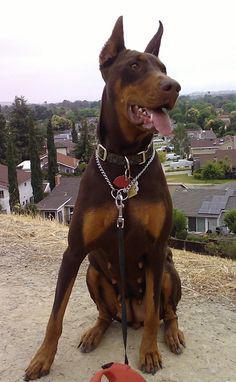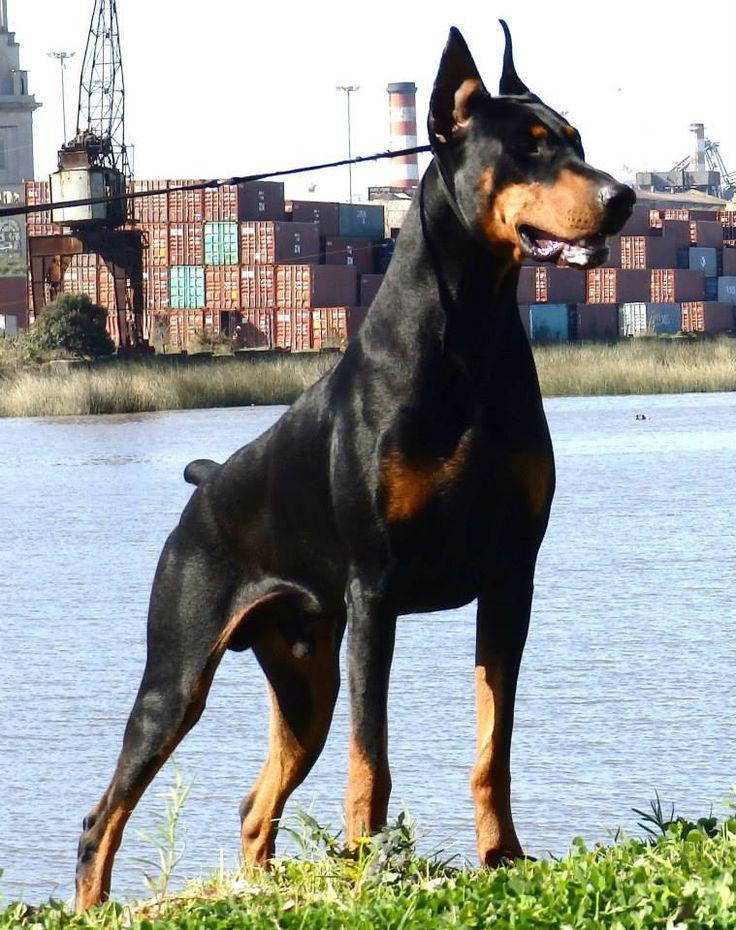The first image is the image on the left, the second image is the image on the right. Given the left and right images, does the statement "All dogs shown have erect ears, each image contains one dog, the dog on the left is sitting upright, and the dog on the right is standing angled rightward." hold true? Answer yes or no. Yes. The first image is the image on the left, the second image is the image on the right. Assess this claim about the two images: "A doberman has its mouth open.". Correct or not? Answer yes or no. Yes. 